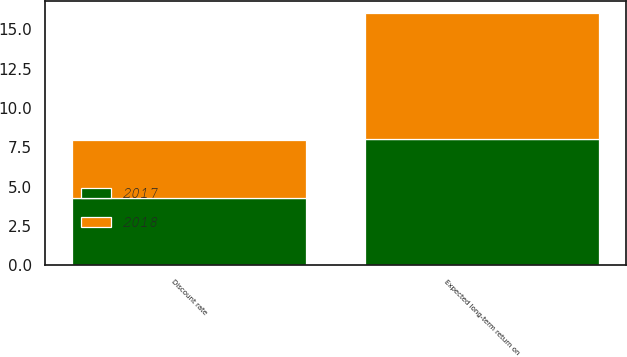Convert chart to OTSL. <chart><loc_0><loc_0><loc_500><loc_500><stacked_bar_chart><ecel><fcel>Discount rate<fcel>Expected long-term return on<nl><fcel>2017<fcel>4.31<fcel>8<nl><fcel>2018<fcel>3.68<fcel>8<nl></chart> 